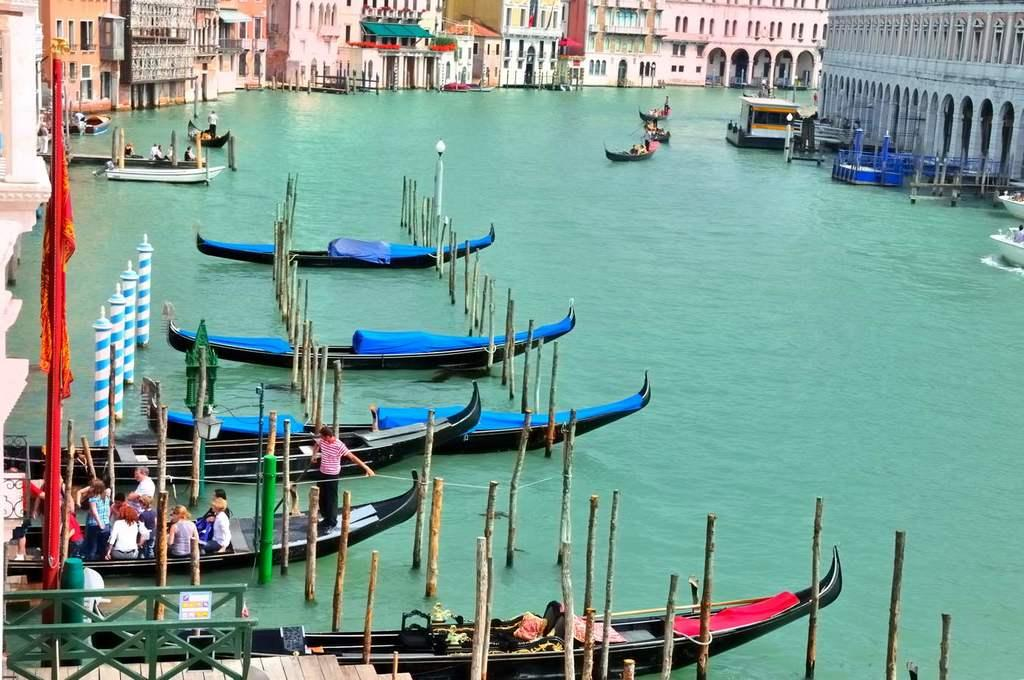What body of water is present in the image? There is a lake in the image. What is on the lake? There are boats on the lake. Who is in the boats? There are people in the boats. What can be seen in the background of the image? There are buildings in the background of the image. What is on the left side of the image? There is a pole on the left side of the image. Can you see any bees flying around the lake in the image? There are no bees visible in the image. What type of oil is being used to lubricate the pole in the image? There is no pole being lubricated with oil in the image. 